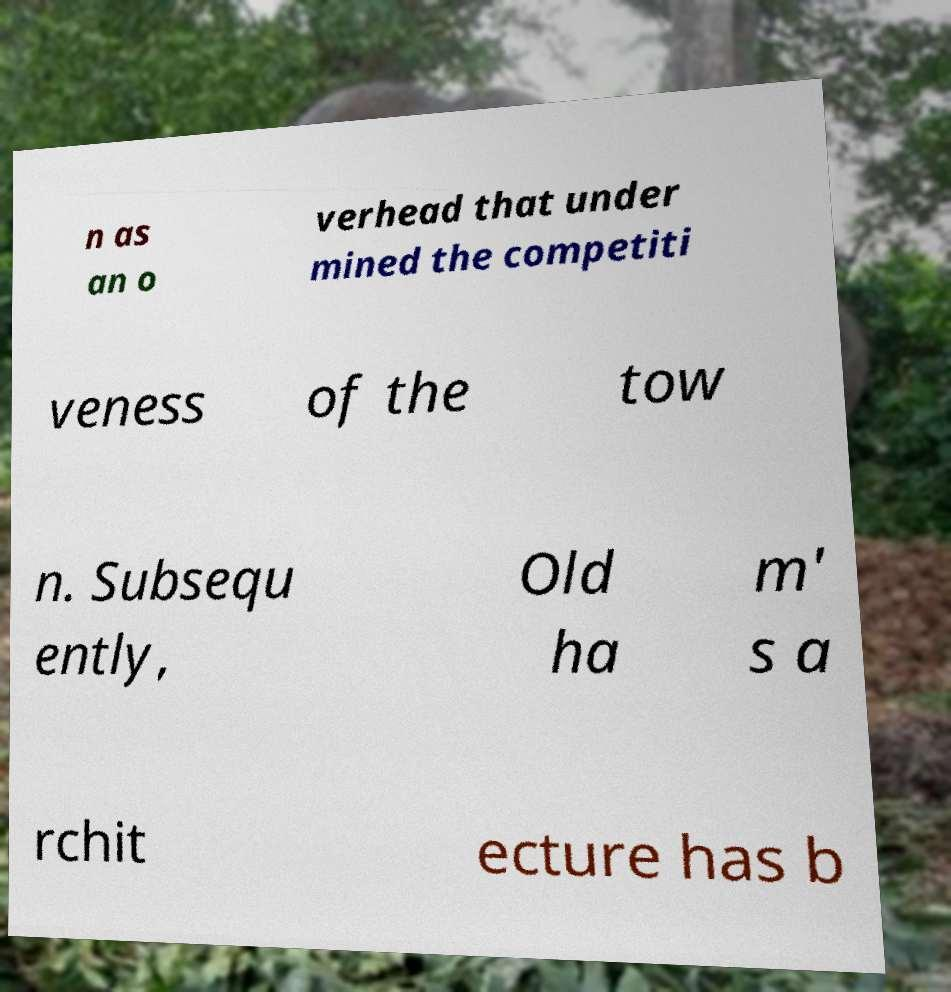Please identify and transcribe the text found in this image. n as an o verhead that under mined the competiti veness of the tow n. Subsequ ently, Old ha m' s a rchit ecture has b 